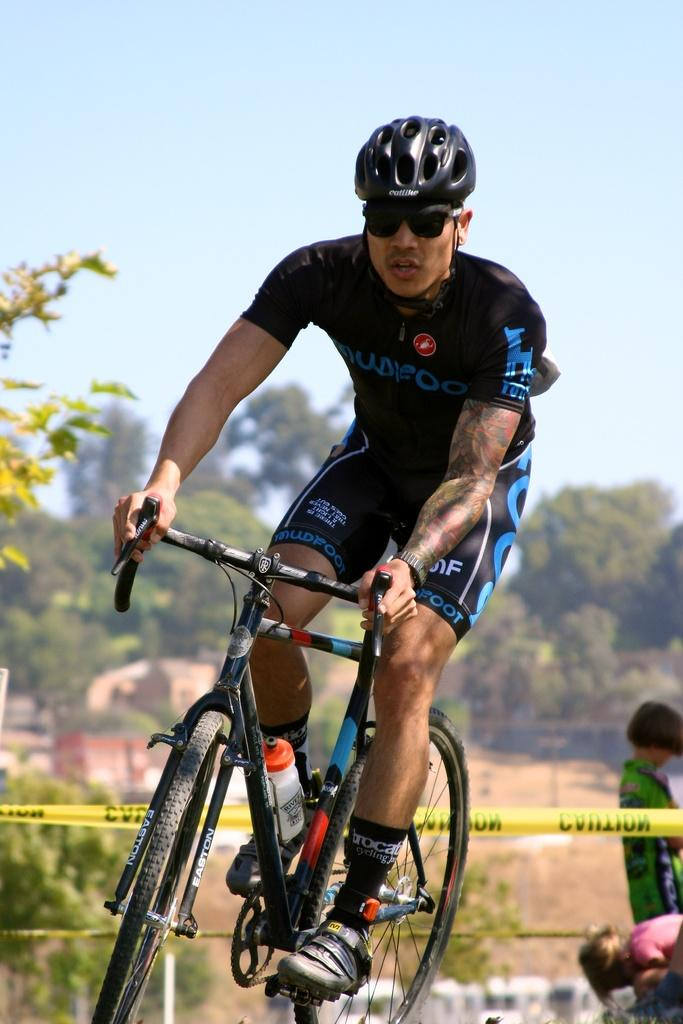What is the main subject of the image? The main subject of the image is a man. What is the man doing in the image? The man is cycling in the image. Can you describe the man's clothing? The man is wearing a black dress in the image. What can be seen in the background of the image? There are trees in the background of the image. What activity is happening to the right of the image? Kids are playing to the right of the image. How would you describe the weather in the image? The sky is clear and sunny in the image. What type of twig is the creature holding in the image? There is no creature or twig present in the image. How is the distribution of the ice cream being managed in the image? There is no ice cream present in the image. 